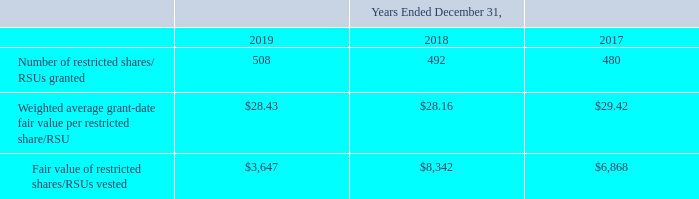The following table summarizes information regarding restricted shares/RSUs granted and vested (in thousands, except per restricted share/RSU amounts):
As of December 31, 2019, based on the probability of achieving the performance goals, there was $6.1 million of total unrecognized compensation cost, net of actual forfeitures, related to nonvested restricted shares/RSUs. Of the unrecognized compensation cost, 33% related to performance-based nonvested restricted shares/RSUs and 67% related to employment-based nonvested restricted shares/RSUs. This cost is expected to be recognized over a weighted average period of 2.0 years.
What is the Number of restricted shares/ RSUs granted in 2019?
Answer scale should be: thousand. 508. What is the Fair value of restricted shares/RSUs vested  in 2018?
Answer scale should be: thousand. $8,342. In which years is the Fair value of restricted shares/RSUs vested calculated? 2019, 2018, 2017. In which year was the Number of restricted shares/ RSUs granted the largest? 508>492>480
Answer: 2019. What was the change in Number of restricted shares/ RSUs granted in 2019 from 2018?
Answer scale should be: thousand. 508-492
Answer: 16. What was the percentage change in Number of restricted shares/ RSUs granted in 2019 from 2018?
Answer scale should be: percent. (508-492)/492
Answer: 3.25. 